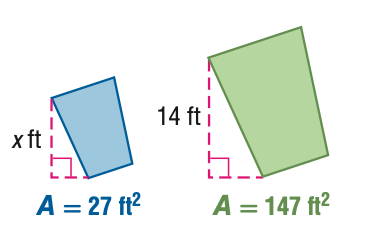Question: For the pair of similar figures, use the given areas to find x.
Choices:
A. 2.6
B. 6.0
C. 32.7
D. 76.2
Answer with the letter. Answer: B 